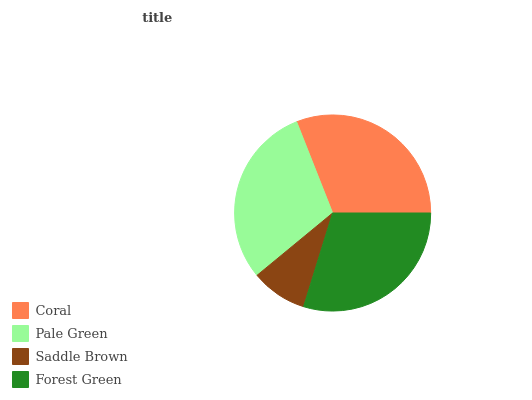Is Saddle Brown the minimum?
Answer yes or no. Yes. Is Coral the maximum?
Answer yes or no. Yes. Is Pale Green the minimum?
Answer yes or no. No. Is Pale Green the maximum?
Answer yes or no. No. Is Coral greater than Pale Green?
Answer yes or no. Yes. Is Pale Green less than Coral?
Answer yes or no. Yes. Is Pale Green greater than Coral?
Answer yes or no. No. Is Coral less than Pale Green?
Answer yes or no. No. Is Pale Green the high median?
Answer yes or no. Yes. Is Forest Green the low median?
Answer yes or no. Yes. Is Forest Green the high median?
Answer yes or no. No. Is Coral the low median?
Answer yes or no. No. 